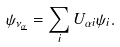Convert formula to latex. <formula><loc_0><loc_0><loc_500><loc_500>\psi _ { { \nu } _ { \underline { \alpha } } } = \sum _ { i } U _ { \alpha i } \psi _ { i } .</formula> 